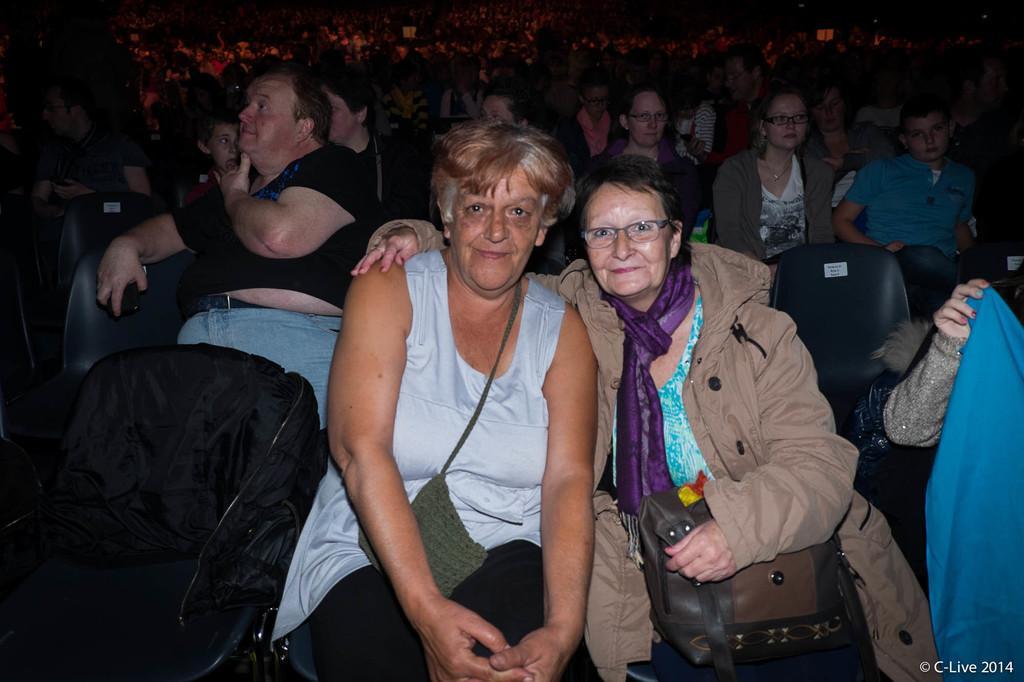How would you summarize this image in a sentence or two? There are many people sitting. In the front a lady on the right side is wearing a scarf and specs and holding a bag. On the left side there is a jacket on the chair. Also there are many chairs. 